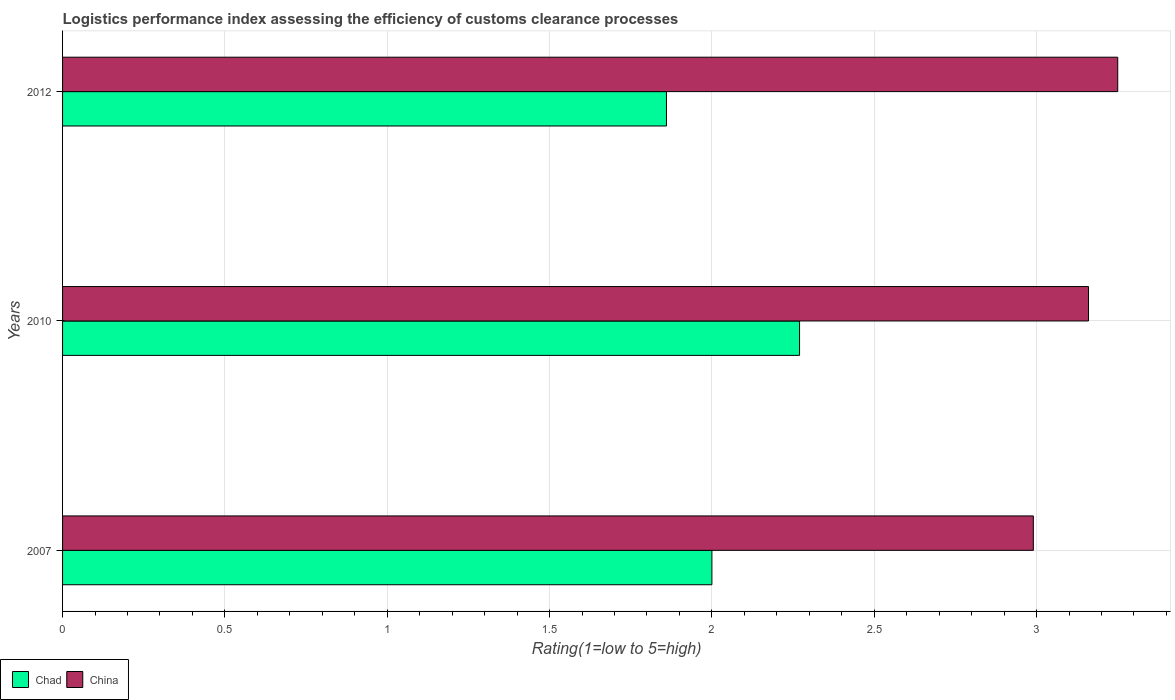How many different coloured bars are there?
Ensure brevity in your answer.  2. How many groups of bars are there?
Ensure brevity in your answer.  3. What is the label of the 1st group of bars from the top?
Your response must be concise. 2012. What is the Logistic performance index in Chad in 2007?
Make the answer very short. 2. Across all years, what is the minimum Logistic performance index in Chad?
Offer a terse response. 1.86. In which year was the Logistic performance index in Chad maximum?
Keep it short and to the point. 2010. What is the difference between the Logistic performance index in China in 2010 and that in 2012?
Keep it short and to the point. -0.09. What is the difference between the Logistic performance index in China in 2010 and the Logistic performance index in Chad in 2007?
Provide a succinct answer. 1.16. What is the average Logistic performance index in China per year?
Offer a very short reply. 3.13. In the year 2007, what is the difference between the Logistic performance index in Chad and Logistic performance index in China?
Make the answer very short. -0.99. What is the ratio of the Logistic performance index in China in 2007 to that in 2010?
Give a very brief answer. 0.95. Is the Logistic performance index in Chad in 2010 less than that in 2012?
Your answer should be compact. No. Is the difference between the Logistic performance index in Chad in 2010 and 2012 greater than the difference between the Logistic performance index in China in 2010 and 2012?
Offer a very short reply. Yes. What is the difference between the highest and the second highest Logistic performance index in China?
Provide a succinct answer. 0.09. What is the difference between the highest and the lowest Logistic performance index in China?
Ensure brevity in your answer.  0.26. Is the sum of the Logistic performance index in China in 2007 and 2010 greater than the maximum Logistic performance index in Chad across all years?
Give a very brief answer. Yes. What does the 1st bar from the top in 2012 represents?
Offer a terse response. China. What does the 2nd bar from the bottom in 2010 represents?
Ensure brevity in your answer.  China. Are all the bars in the graph horizontal?
Your answer should be very brief. Yes. How many years are there in the graph?
Give a very brief answer. 3. Does the graph contain any zero values?
Keep it short and to the point. No. Does the graph contain grids?
Provide a succinct answer. Yes. Where does the legend appear in the graph?
Keep it short and to the point. Bottom left. How many legend labels are there?
Provide a short and direct response. 2. What is the title of the graph?
Provide a short and direct response. Logistics performance index assessing the efficiency of customs clearance processes. Does "Sudan" appear as one of the legend labels in the graph?
Ensure brevity in your answer.  No. What is the label or title of the X-axis?
Offer a very short reply. Rating(1=low to 5=high). What is the label or title of the Y-axis?
Make the answer very short. Years. What is the Rating(1=low to 5=high) in Chad in 2007?
Keep it short and to the point. 2. What is the Rating(1=low to 5=high) of China in 2007?
Make the answer very short. 2.99. What is the Rating(1=low to 5=high) in Chad in 2010?
Ensure brevity in your answer.  2.27. What is the Rating(1=low to 5=high) of China in 2010?
Your answer should be very brief. 3.16. What is the Rating(1=low to 5=high) in Chad in 2012?
Make the answer very short. 1.86. Across all years, what is the maximum Rating(1=low to 5=high) in Chad?
Your answer should be compact. 2.27. Across all years, what is the minimum Rating(1=low to 5=high) in Chad?
Ensure brevity in your answer.  1.86. Across all years, what is the minimum Rating(1=low to 5=high) in China?
Provide a short and direct response. 2.99. What is the total Rating(1=low to 5=high) of Chad in the graph?
Offer a terse response. 6.13. What is the total Rating(1=low to 5=high) in China in the graph?
Give a very brief answer. 9.4. What is the difference between the Rating(1=low to 5=high) in Chad in 2007 and that in 2010?
Give a very brief answer. -0.27. What is the difference between the Rating(1=low to 5=high) of China in 2007 and that in 2010?
Give a very brief answer. -0.17. What is the difference between the Rating(1=low to 5=high) of Chad in 2007 and that in 2012?
Give a very brief answer. 0.14. What is the difference between the Rating(1=low to 5=high) of China in 2007 and that in 2012?
Keep it short and to the point. -0.26. What is the difference between the Rating(1=low to 5=high) of Chad in 2010 and that in 2012?
Provide a short and direct response. 0.41. What is the difference between the Rating(1=low to 5=high) in China in 2010 and that in 2012?
Provide a succinct answer. -0.09. What is the difference between the Rating(1=low to 5=high) in Chad in 2007 and the Rating(1=low to 5=high) in China in 2010?
Provide a succinct answer. -1.16. What is the difference between the Rating(1=low to 5=high) of Chad in 2007 and the Rating(1=low to 5=high) of China in 2012?
Offer a terse response. -1.25. What is the difference between the Rating(1=low to 5=high) of Chad in 2010 and the Rating(1=low to 5=high) of China in 2012?
Give a very brief answer. -0.98. What is the average Rating(1=low to 5=high) of Chad per year?
Your response must be concise. 2.04. What is the average Rating(1=low to 5=high) in China per year?
Keep it short and to the point. 3.13. In the year 2007, what is the difference between the Rating(1=low to 5=high) in Chad and Rating(1=low to 5=high) in China?
Your answer should be very brief. -0.99. In the year 2010, what is the difference between the Rating(1=low to 5=high) in Chad and Rating(1=low to 5=high) in China?
Keep it short and to the point. -0.89. In the year 2012, what is the difference between the Rating(1=low to 5=high) of Chad and Rating(1=low to 5=high) of China?
Your answer should be compact. -1.39. What is the ratio of the Rating(1=low to 5=high) in Chad in 2007 to that in 2010?
Offer a terse response. 0.88. What is the ratio of the Rating(1=low to 5=high) in China in 2007 to that in 2010?
Give a very brief answer. 0.95. What is the ratio of the Rating(1=low to 5=high) of Chad in 2007 to that in 2012?
Your response must be concise. 1.08. What is the ratio of the Rating(1=low to 5=high) in China in 2007 to that in 2012?
Offer a very short reply. 0.92. What is the ratio of the Rating(1=low to 5=high) of Chad in 2010 to that in 2012?
Keep it short and to the point. 1.22. What is the ratio of the Rating(1=low to 5=high) of China in 2010 to that in 2012?
Provide a succinct answer. 0.97. What is the difference between the highest and the second highest Rating(1=low to 5=high) in Chad?
Offer a terse response. 0.27. What is the difference between the highest and the second highest Rating(1=low to 5=high) in China?
Make the answer very short. 0.09. What is the difference between the highest and the lowest Rating(1=low to 5=high) in Chad?
Ensure brevity in your answer.  0.41. What is the difference between the highest and the lowest Rating(1=low to 5=high) in China?
Keep it short and to the point. 0.26. 